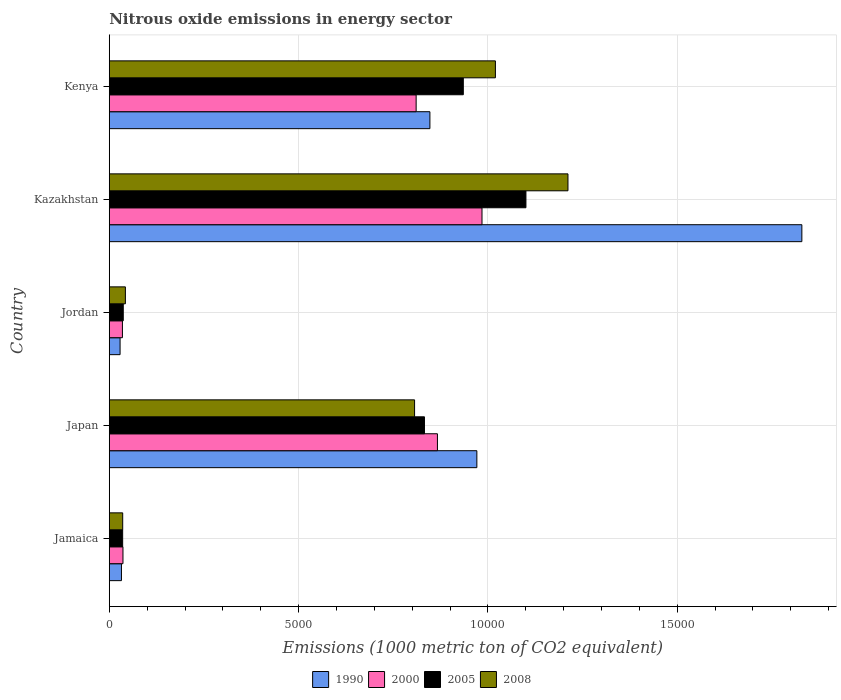How many groups of bars are there?
Offer a very short reply. 5. Are the number of bars on each tick of the Y-axis equal?
Your answer should be compact. Yes. How many bars are there on the 2nd tick from the top?
Ensure brevity in your answer.  4. How many bars are there on the 2nd tick from the bottom?
Your answer should be compact. 4. What is the label of the 4th group of bars from the top?
Provide a succinct answer. Japan. In how many cases, is the number of bars for a given country not equal to the number of legend labels?
Provide a succinct answer. 0. What is the amount of nitrous oxide emitted in 1990 in Jamaica?
Your answer should be very brief. 321.7. Across all countries, what is the maximum amount of nitrous oxide emitted in 2005?
Your answer should be very brief. 1.10e+04. Across all countries, what is the minimum amount of nitrous oxide emitted in 2005?
Your answer should be very brief. 353.5. In which country was the amount of nitrous oxide emitted in 2008 maximum?
Ensure brevity in your answer.  Kazakhstan. In which country was the amount of nitrous oxide emitted in 1990 minimum?
Ensure brevity in your answer.  Jordan. What is the total amount of nitrous oxide emitted in 2008 in the graph?
Provide a short and direct response. 3.12e+04. What is the difference between the amount of nitrous oxide emitted in 2008 in Japan and that in Kazakhstan?
Ensure brevity in your answer.  -4051.4. What is the difference between the amount of nitrous oxide emitted in 2008 in Kazakhstan and the amount of nitrous oxide emitted in 1990 in Kenya?
Provide a succinct answer. 3646.6. What is the average amount of nitrous oxide emitted in 1990 per country?
Your answer should be very brief. 7415.42. What is the difference between the amount of nitrous oxide emitted in 1990 and amount of nitrous oxide emitted in 2005 in Jordan?
Provide a succinct answer. -83.9. What is the ratio of the amount of nitrous oxide emitted in 2008 in Jamaica to that in Kenya?
Your answer should be compact. 0.03. Is the amount of nitrous oxide emitted in 2000 in Jamaica less than that in Kazakhstan?
Offer a terse response. Yes. What is the difference between the highest and the second highest amount of nitrous oxide emitted in 2005?
Your response must be concise. 1654. What is the difference between the highest and the lowest amount of nitrous oxide emitted in 2000?
Provide a succinct answer. 9497.1. Is the sum of the amount of nitrous oxide emitted in 2008 in Jamaica and Kazakhstan greater than the maximum amount of nitrous oxide emitted in 2005 across all countries?
Ensure brevity in your answer.  Yes. Is it the case that in every country, the sum of the amount of nitrous oxide emitted in 2005 and amount of nitrous oxide emitted in 1990 is greater than the sum of amount of nitrous oxide emitted in 2000 and amount of nitrous oxide emitted in 2008?
Your answer should be very brief. No. What does the 2nd bar from the bottom in Kenya represents?
Ensure brevity in your answer.  2000. How many bars are there?
Give a very brief answer. 20. Are all the bars in the graph horizontal?
Provide a succinct answer. Yes. How many countries are there in the graph?
Offer a very short reply. 5. Does the graph contain grids?
Provide a succinct answer. Yes. Where does the legend appear in the graph?
Make the answer very short. Bottom center. How many legend labels are there?
Provide a succinct answer. 4. How are the legend labels stacked?
Your answer should be compact. Horizontal. What is the title of the graph?
Offer a very short reply. Nitrous oxide emissions in energy sector. What is the label or title of the X-axis?
Offer a terse response. Emissions (1000 metric ton of CO2 equivalent). What is the label or title of the Y-axis?
Make the answer very short. Country. What is the Emissions (1000 metric ton of CO2 equivalent) in 1990 in Jamaica?
Provide a short and direct response. 321.7. What is the Emissions (1000 metric ton of CO2 equivalent) in 2000 in Jamaica?
Provide a succinct answer. 361.6. What is the Emissions (1000 metric ton of CO2 equivalent) in 2005 in Jamaica?
Keep it short and to the point. 353.5. What is the Emissions (1000 metric ton of CO2 equivalent) in 2008 in Jamaica?
Ensure brevity in your answer.  354.8. What is the Emissions (1000 metric ton of CO2 equivalent) of 1990 in Japan?
Your answer should be very brief. 9708.8. What is the Emissions (1000 metric ton of CO2 equivalent) of 2000 in Japan?
Your response must be concise. 8667.2. What is the Emissions (1000 metric ton of CO2 equivalent) in 2005 in Japan?
Your response must be concise. 8324.7. What is the Emissions (1000 metric ton of CO2 equivalent) of 2008 in Japan?
Provide a succinct answer. 8063.7. What is the Emissions (1000 metric ton of CO2 equivalent) in 1990 in Jordan?
Give a very brief answer. 285.6. What is the Emissions (1000 metric ton of CO2 equivalent) of 2000 in Jordan?
Keep it short and to the point. 347.2. What is the Emissions (1000 metric ton of CO2 equivalent) in 2005 in Jordan?
Ensure brevity in your answer.  369.5. What is the Emissions (1000 metric ton of CO2 equivalent) in 2008 in Jordan?
Ensure brevity in your answer.  425.7. What is the Emissions (1000 metric ton of CO2 equivalent) in 1990 in Kazakhstan?
Your answer should be compact. 1.83e+04. What is the Emissions (1000 metric ton of CO2 equivalent) in 2000 in Kazakhstan?
Your response must be concise. 9844.3. What is the Emissions (1000 metric ton of CO2 equivalent) in 2005 in Kazakhstan?
Make the answer very short. 1.10e+04. What is the Emissions (1000 metric ton of CO2 equivalent) of 2008 in Kazakhstan?
Offer a terse response. 1.21e+04. What is the Emissions (1000 metric ton of CO2 equivalent) in 1990 in Kenya?
Ensure brevity in your answer.  8468.5. What is the Emissions (1000 metric ton of CO2 equivalent) of 2000 in Kenya?
Provide a succinct answer. 8105.1. What is the Emissions (1000 metric ton of CO2 equivalent) of 2005 in Kenya?
Ensure brevity in your answer.  9351. What is the Emissions (1000 metric ton of CO2 equivalent) of 2008 in Kenya?
Offer a very short reply. 1.02e+04. Across all countries, what is the maximum Emissions (1000 metric ton of CO2 equivalent) of 1990?
Your response must be concise. 1.83e+04. Across all countries, what is the maximum Emissions (1000 metric ton of CO2 equivalent) in 2000?
Make the answer very short. 9844.3. Across all countries, what is the maximum Emissions (1000 metric ton of CO2 equivalent) in 2005?
Keep it short and to the point. 1.10e+04. Across all countries, what is the maximum Emissions (1000 metric ton of CO2 equivalent) of 2008?
Make the answer very short. 1.21e+04. Across all countries, what is the minimum Emissions (1000 metric ton of CO2 equivalent) of 1990?
Give a very brief answer. 285.6. Across all countries, what is the minimum Emissions (1000 metric ton of CO2 equivalent) of 2000?
Provide a short and direct response. 347.2. Across all countries, what is the minimum Emissions (1000 metric ton of CO2 equivalent) of 2005?
Your answer should be very brief. 353.5. Across all countries, what is the minimum Emissions (1000 metric ton of CO2 equivalent) in 2008?
Ensure brevity in your answer.  354.8. What is the total Emissions (1000 metric ton of CO2 equivalent) in 1990 in the graph?
Your answer should be very brief. 3.71e+04. What is the total Emissions (1000 metric ton of CO2 equivalent) of 2000 in the graph?
Provide a short and direct response. 2.73e+04. What is the total Emissions (1000 metric ton of CO2 equivalent) in 2005 in the graph?
Give a very brief answer. 2.94e+04. What is the total Emissions (1000 metric ton of CO2 equivalent) of 2008 in the graph?
Keep it short and to the point. 3.12e+04. What is the difference between the Emissions (1000 metric ton of CO2 equivalent) of 1990 in Jamaica and that in Japan?
Give a very brief answer. -9387.1. What is the difference between the Emissions (1000 metric ton of CO2 equivalent) of 2000 in Jamaica and that in Japan?
Make the answer very short. -8305.6. What is the difference between the Emissions (1000 metric ton of CO2 equivalent) in 2005 in Jamaica and that in Japan?
Keep it short and to the point. -7971.2. What is the difference between the Emissions (1000 metric ton of CO2 equivalent) of 2008 in Jamaica and that in Japan?
Offer a very short reply. -7708.9. What is the difference between the Emissions (1000 metric ton of CO2 equivalent) in 1990 in Jamaica and that in Jordan?
Offer a terse response. 36.1. What is the difference between the Emissions (1000 metric ton of CO2 equivalent) of 2000 in Jamaica and that in Jordan?
Ensure brevity in your answer.  14.4. What is the difference between the Emissions (1000 metric ton of CO2 equivalent) in 2008 in Jamaica and that in Jordan?
Give a very brief answer. -70.9. What is the difference between the Emissions (1000 metric ton of CO2 equivalent) of 1990 in Jamaica and that in Kazakhstan?
Offer a very short reply. -1.80e+04. What is the difference between the Emissions (1000 metric ton of CO2 equivalent) in 2000 in Jamaica and that in Kazakhstan?
Provide a succinct answer. -9482.7. What is the difference between the Emissions (1000 metric ton of CO2 equivalent) in 2005 in Jamaica and that in Kazakhstan?
Your response must be concise. -1.07e+04. What is the difference between the Emissions (1000 metric ton of CO2 equivalent) in 2008 in Jamaica and that in Kazakhstan?
Offer a terse response. -1.18e+04. What is the difference between the Emissions (1000 metric ton of CO2 equivalent) in 1990 in Jamaica and that in Kenya?
Your answer should be compact. -8146.8. What is the difference between the Emissions (1000 metric ton of CO2 equivalent) of 2000 in Jamaica and that in Kenya?
Give a very brief answer. -7743.5. What is the difference between the Emissions (1000 metric ton of CO2 equivalent) in 2005 in Jamaica and that in Kenya?
Your response must be concise. -8997.5. What is the difference between the Emissions (1000 metric ton of CO2 equivalent) of 2008 in Jamaica and that in Kenya?
Offer a terse response. -9843.7. What is the difference between the Emissions (1000 metric ton of CO2 equivalent) in 1990 in Japan and that in Jordan?
Keep it short and to the point. 9423.2. What is the difference between the Emissions (1000 metric ton of CO2 equivalent) of 2000 in Japan and that in Jordan?
Make the answer very short. 8320. What is the difference between the Emissions (1000 metric ton of CO2 equivalent) in 2005 in Japan and that in Jordan?
Your answer should be compact. 7955.2. What is the difference between the Emissions (1000 metric ton of CO2 equivalent) of 2008 in Japan and that in Jordan?
Make the answer very short. 7638. What is the difference between the Emissions (1000 metric ton of CO2 equivalent) of 1990 in Japan and that in Kazakhstan?
Provide a short and direct response. -8583.7. What is the difference between the Emissions (1000 metric ton of CO2 equivalent) of 2000 in Japan and that in Kazakhstan?
Ensure brevity in your answer.  -1177.1. What is the difference between the Emissions (1000 metric ton of CO2 equivalent) of 2005 in Japan and that in Kazakhstan?
Offer a very short reply. -2680.3. What is the difference between the Emissions (1000 metric ton of CO2 equivalent) in 2008 in Japan and that in Kazakhstan?
Keep it short and to the point. -4051.4. What is the difference between the Emissions (1000 metric ton of CO2 equivalent) of 1990 in Japan and that in Kenya?
Provide a succinct answer. 1240.3. What is the difference between the Emissions (1000 metric ton of CO2 equivalent) in 2000 in Japan and that in Kenya?
Offer a very short reply. 562.1. What is the difference between the Emissions (1000 metric ton of CO2 equivalent) in 2005 in Japan and that in Kenya?
Your response must be concise. -1026.3. What is the difference between the Emissions (1000 metric ton of CO2 equivalent) of 2008 in Japan and that in Kenya?
Offer a terse response. -2134.8. What is the difference between the Emissions (1000 metric ton of CO2 equivalent) of 1990 in Jordan and that in Kazakhstan?
Offer a very short reply. -1.80e+04. What is the difference between the Emissions (1000 metric ton of CO2 equivalent) in 2000 in Jordan and that in Kazakhstan?
Your response must be concise. -9497.1. What is the difference between the Emissions (1000 metric ton of CO2 equivalent) in 2005 in Jordan and that in Kazakhstan?
Your answer should be very brief. -1.06e+04. What is the difference between the Emissions (1000 metric ton of CO2 equivalent) of 2008 in Jordan and that in Kazakhstan?
Provide a succinct answer. -1.17e+04. What is the difference between the Emissions (1000 metric ton of CO2 equivalent) of 1990 in Jordan and that in Kenya?
Your response must be concise. -8182.9. What is the difference between the Emissions (1000 metric ton of CO2 equivalent) of 2000 in Jordan and that in Kenya?
Provide a short and direct response. -7757.9. What is the difference between the Emissions (1000 metric ton of CO2 equivalent) of 2005 in Jordan and that in Kenya?
Make the answer very short. -8981.5. What is the difference between the Emissions (1000 metric ton of CO2 equivalent) of 2008 in Jordan and that in Kenya?
Offer a terse response. -9772.8. What is the difference between the Emissions (1000 metric ton of CO2 equivalent) in 1990 in Kazakhstan and that in Kenya?
Ensure brevity in your answer.  9824. What is the difference between the Emissions (1000 metric ton of CO2 equivalent) in 2000 in Kazakhstan and that in Kenya?
Your response must be concise. 1739.2. What is the difference between the Emissions (1000 metric ton of CO2 equivalent) of 2005 in Kazakhstan and that in Kenya?
Make the answer very short. 1654. What is the difference between the Emissions (1000 metric ton of CO2 equivalent) in 2008 in Kazakhstan and that in Kenya?
Your answer should be compact. 1916.6. What is the difference between the Emissions (1000 metric ton of CO2 equivalent) in 1990 in Jamaica and the Emissions (1000 metric ton of CO2 equivalent) in 2000 in Japan?
Offer a very short reply. -8345.5. What is the difference between the Emissions (1000 metric ton of CO2 equivalent) in 1990 in Jamaica and the Emissions (1000 metric ton of CO2 equivalent) in 2005 in Japan?
Make the answer very short. -8003. What is the difference between the Emissions (1000 metric ton of CO2 equivalent) of 1990 in Jamaica and the Emissions (1000 metric ton of CO2 equivalent) of 2008 in Japan?
Provide a succinct answer. -7742. What is the difference between the Emissions (1000 metric ton of CO2 equivalent) in 2000 in Jamaica and the Emissions (1000 metric ton of CO2 equivalent) in 2005 in Japan?
Offer a very short reply. -7963.1. What is the difference between the Emissions (1000 metric ton of CO2 equivalent) in 2000 in Jamaica and the Emissions (1000 metric ton of CO2 equivalent) in 2008 in Japan?
Your answer should be compact. -7702.1. What is the difference between the Emissions (1000 metric ton of CO2 equivalent) of 2005 in Jamaica and the Emissions (1000 metric ton of CO2 equivalent) of 2008 in Japan?
Ensure brevity in your answer.  -7710.2. What is the difference between the Emissions (1000 metric ton of CO2 equivalent) of 1990 in Jamaica and the Emissions (1000 metric ton of CO2 equivalent) of 2000 in Jordan?
Make the answer very short. -25.5. What is the difference between the Emissions (1000 metric ton of CO2 equivalent) in 1990 in Jamaica and the Emissions (1000 metric ton of CO2 equivalent) in 2005 in Jordan?
Provide a succinct answer. -47.8. What is the difference between the Emissions (1000 metric ton of CO2 equivalent) of 1990 in Jamaica and the Emissions (1000 metric ton of CO2 equivalent) of 2008 in Jordan?
Offer a very short reply. -104. What is the difference between the Emissions (1000 metric ton of CO2 equivalent) in 2000 in Jamaica and the Emissions (1000 metric ton of CO2 equivalent) in 2005 in Jordan?
Offer a terse response. -7.9. What is the difference between the Emissions (1000 metric ton of CO2 equivalent) of 2000 in Jamaica and the Emissions (1000 metric ton of CO2 equivalent) of 2008 in Jordan?
Ensure brevity in your answer.  -64.1. What is the difference between the Emissions (1000 metric ton of CO2 equivalent) of 2005 in Jamaica and the Emissions (1000 metric ton of CO2 equivalent) of 2008 in Jordan?
Your answer should be very brief. -72.2. What is the difference between the Emissions (1000 metric ton of CO2 equivalent) of 1990 in Jamaica and the Emissions (1000 metric ton of CO2 equivalent) of 2000 in Kazakhstan?
Ensure brevity in your answer.  -9522.6. What is the difference between the Emissions (1000 metric ton of CO2 equivalent) in 1990 in Jamaica and the Emissions (1000 metric ton of CO2 equivalent) in 2005 in Kazakhstan?
Offer a terse response. -1.07e+04. What is the difference between the Emissions (1000 metric ton of CO2 equivalent) of 1990 in Jamaica and the Emissions (1000 metric ton of CO2 equivalent) of 2008 in Kazakhstan?
Provide a succinct answer. -1.18e+04. What is the difference between the Emissions (1000 metric ton of CO2 equivalent) in 2000 in Jamaica and the Emissions (1000 metric ton of CO2 equivalent) in 2005 in Kazakhstan?
Your answer should be compact. -1.06e+04. What is the difference between the Emissions (1000 metric ton of CO2 equivalent) of 2000 in Jamaica and the Emissions (1000 metric ton of CO2 equivalent) of 2008 in Kazakhstan?
Offer a very short reply. -1.18e+04. What is the difference between the Emissions (1000 metric ton of CO2 equivalent) in 2005 in Jamaica and the Emissions (1000 metric ton of CO2 equivalent) in 2008 in Kazakhstan?
Provide a short and direct response. -1.18e+04. What is the difference between the Emissions (1000 metric ton of CO2 equivalent) of 1990 in Jamaica and the Emissions (1000 metric ton of CO2 equivalent) of 2000 in Kenya?
Your answer should be compact. -7783.4. What is the difference between the Emissions (1000 metric ton of CO2 equivalent) in 1990 in Jamaica and the Emissions (1000 metric ton of CO2 equivalent) in 2005 in Kenya?
Provide a succinct answer. -9029.3. What is the difference between the Emissions (1000 metric ton of CO2 equivalent) of 1990 in Jamaica and the Emissions (1000 metric ton of CO2 equivalent) of 2008 in Kenya?
Make the answer very short. -9876.8. What is the difference between the Emissions (1000 metric ton of CO2 equivalent) of 2000 in Jamaica and the Emissions (1000 metric ton of CO2 equivalent) of 2005 in Kenya?
Ensure brevity in your answer.  -8989.4. What is the difference between the Emissions (1000 metric ton of CO2 equivalent) in 2000 in Jamaica and the Emissions (1000 metric ton of CO2 equivalent) in 2008 in Kenya?
Provide a short and direct response. -9836.9. What is the difference between the Emissions (1000 metric ton of CO2 equivalent) in 2005 in Jamaica and the Emissions (1000 metric ton of CO2 equivalent) in 2008 in Kenya?
Give a very brief answer. -9845. What is the difference between the Emissions (1000 metric ton of CO2 equivalent) in 1990 in Japan and the Emissions (1000 metric ton of CO2 equivalent) in 2000 in Jordan?
Provide a succinct answer. 9361.6. What is the difference between the Emissions (1000 metric ton of CO2 equivalent) of 1990 in Japan and the Emissions (1000 metric ton of CO2 equivalent) of 2005 in Jordan?
Offer a terse response. 9339.3. What is the difference between the Emissions (1000 metric ton of CO2 equivalent) of 1990 in Japan and the Emissions (1000 metric ton of CO2 equivalent) of 2008 in Jordan?
Keep it short and to the point. 9283.1. What is the difference between the Emissions (1000 metric ton of CO2 equivalent) in 2000 in Japan and the Emissions (1000 metric ton of CO2 equivalent) in 2005 in Jordan?
Provide a succinct answer. 8297.7. What is the difference between the Emissions (1000 metric ton of CO2 equivalent) of 2000 in Japan and the Emissions (1000 metric ton of CO2 equivalent) of 2008 in Jordan?
Offer a very short reply. 8241.5. What is the difference between the Emissions (1000 metric ton of CO2 equivalent) in 2005 in Japan and the Emissions (1000 metric ton of CO2 equivalent) in 2008 in Jordan?
Offer a very short reply. 7899. What is the difference between the Emissions (1000 metric ton of CO2 equivalent) of 1990 in Japan and the Emissions (1000 metric ton of CO2 equivalent) of 2000 in Kazakhstan?
Your answer should be compact. -135.5. What is the difference between the Emissions (1000 metric ton of CO2 equivalent) of 1990 in Japan and the Emissions (1000 metric ton of CO2 equivalent) of 2005 in Kazakhstan?
Provide a succinct answer. -1296.2. What is the difference between the Emissions (1000 metric ton of CO2 equivalent) of 1990 in Japan and the Emissions (1000 metric ton of CO2 equivalent) of 2008 in Kazakhstan?
Provide a short and direct response. -2406.3. What is the difference between the Emissions (1000 metric ton of CO2 equivalent) of 2000 in Japan and the Emissions (1000 metric ton of CO2 equivalent) of 2005 in Kazakhstan?
Make the answer very short. -2337.8. What is the difference between the Emissions (1000 metric ton of CO2 equivalent) of 2000 in Japan and the Emissions (1000 metric ton of CO2 equivalent) of 2008 in Kazakhstan?
Offer a terse response. -3447.9. What is the difference between the Emissions (1000 metric ton of CO2 equivalent) of 2005 in Japan and the Emissions (1000 metric ton of CO2 equivalent) of 2008 in Kazakhstan?
Your answer should be compact. -3790.4. What is the difference between the Emissions (1000 metric ton of CO2 equivalent) in 1990 in Japan and the Emissions (1000 metric ton of CO2 equivalent) in 2000 in Kenya?
Make the answer very short. 1603.7. What is the difference between the Emissions (1000 metric ton of CO2 equivalent) of 1990 in Japan and the Emissions (1000 metric ton of CO2 equivalent) of 2005 in Kenya?
Offer a very short reply. 357.8. What is the difference between the Emissions (1000 metric ton of CO2 equivalent) in 1990 in Japan and the Emissions (1000 metric ton of CO2 equivalent) in 2008 in Kenya?
Ensure brevity in your answer.  -489.7. What is the difference between the Emissions (1000 metric ton of CO2 equivalent) of 2000 in Japan and the Emissions (1000 metric ton of CO2 equivalent) of 2005 in Kenya?
Offer a very short reply. -683.8. What is the difference between the Emissions (1000 metric ton of CO2 equivalent) in 2000 in Japan and the Emissions (1000 metric ton of CO2 equivalent) in 2008 in Kenya?
Offer a very short reply. -1531.3. What is the difference between the Emissions (1000 metric ton of CO2 equivalent) of 2005 in Japan and the Emissions (1000 metric ton of CO2 equivalent) of 2008 in Kenya?
Keep it short and to the point. -1873.8. What is the difference between the Emissions (1000 metric ton of CO2 equivalent) of 1990 in Jordan and the Emissions (1000 metric ton of CO2 equivalent) of 2000 in Kazakhstan?
Your response must be concise. -9558.7. What is the difference between the Emissions (1000 metric ton of CO2 equivalent) of 1990 in Jordan and the Emissions (1000 metric ton of CO2 equivalent) of 2005 in Kazakhstan?
Your answer should be very brief. -1.07e+04. What is the difference between the Emissions (1000 metric ton of CO2 equivalent) in 1990 in Jordan and the Emissions (1000 metric ton of CO2 equivalent) in 2008 in Kazakhstan?
Your answer should be very brief. -1.18e+04. What is the difference between the Emissions (1000 metric ton of CO2 equivalent) of 2000 in Jordan and the Emissions (1000 metric ton of CO2 equivalent) of 2005 in Kazakhstan?
Keep it short and to the point. -1.07e+04. What is the difference between the Emissions (1000 metric ton of CO2 equivalent) in 2000 in Jordan and the Emissions (1000 metric ton of CO2 equivalent) in 2008 in Kazakhstan?
Offer a very short reply. -1.18e+04. What is the difference between the Emissions (1000 metric ton of CO2 equivalent) in 2005 in Jordan and the Emissions (1000 metric ton of CO2 equivalent) in 2008 in Kazakhstan?
Provide a short and direct response. -1.17e+04. What is the difference between the Emissions (1000 metric ton of CO2 equivalent) of 1990 in Jordan and the Emissions (1000 metric ton of CO2 equivalent) of 2000 in Kenya?
Ensure brevity in your answer.  -7819.5. What is the difference between the Emissions (1000 metric ton of CO2 equivalent) of 1990 in Jordan and the Emissions (1000 metric ton of CO2 equivalent) of 2005 in Kenya?
Your response must be concise. -9065.4. What is the difference between the Emissions (1000 metric ton of CO2 equivalent) in 1990 in Jordan and the Emissions (1000 metric ton of CO2 equivalent) in 2008 in Kenya?
Give a very brief answer. -9912.9. What is the difference between the Emissions (1000 metric ton of CO2 equivalent) in 2000 in Jordan and the Emissions (1000 metric ton of CO2 equivalent) in 2005 in Kenya?
Your response must be concise. -9003.8. What is the difference between the Emissions (1000 metric ton of CO2 equivalent) of 2000 in Jordan and the Emissions (1000 metric ton of CO2 equivalent) of 2008 in Kenya?
Make the answer very short. -9851.3. What is the difference between the Emissions (1000 metric ton of CO2 equivalent) of 2005 in Jordan and the Emissions (1000 metric ton of CO2 equivalent) of 2008 in Kenya?
Give a very brief answer. -9829. What is the difference between the Emissions (1000 metric ton of CO2 equivalent) in 1990 in Kazakhstan and the Emissions (1000 metric ton of CO2 equivalent) in 2000 in Kenya?
Make the answer very short. 1.02e+04. What is the difference between the Emissions (1000 metric ton of CO2 equivalent) of 1990 in Kazakhstan and the Emissions (1000 metric ton of CO2 equivalent) of 2005 in Kenya?
Your response must be concise. 8941.5. What is the difference between the Emissions (1000 metric ton of CO2 equivalent) in 1990 in Kazakhstan and the Emissions (1000 metric ton of CO2 equivalent) in 2008 in Kenya?
Your answer should be very brief. 8094. What is the difference between the Emissions (1000 metric ton of CO2 equivalent) of 2000 in Kazakhstan and the Emissions (1000 metric ton of CO2 equivalent) of 2005 in Kenya?
Your answer should be very brief. 493.3. What is the difference between the Emissions (1000 metric ton of CO2 equivalent) in 2000 in Kazakhstan and the Emissions (1000 metric ton of CO2 equivalent) in 2008 in Kenya?
Your answer should be compact. -354.2. What is the difference between the Emissions (1000 metric ton of CO2 equivalent) of 2005 in Kazakhstan and the Emissions (1000 metric ton of CO2 equivalent) of 2008 in Kenya?
Your response must be concise. 806.5. What is the average Emissions (1000 metric ton of CO2 equivalent) in 1990 per country?
Offer a terse response. 7415.42. What is the average Emissions (1000 metric ton of CO2 equivalent) in 2000 per country?
Keep it short and to the point. 5465.08. What is the average Emissions (1000 metric ton of CO2 equivalent) of 2005 per country?
Offer a terse response. 5880.74. What is the average Emissions (1000 metric ton of CO2 equivalent) of 2008 per country?
Ensure brevity in your answer.  6231.56. What is the difference between the Emissions (1000 metric ton of CO2 equivalent) of 1990 and Emissions (1000 metric ton of CO2 equivalent) of 2000 in Jamaica?
Offer a terse response. -39.9. What is the difference between the Emissions (1000 metric ton of CO2 equivalent) in 1990 and Emissions (1000 metric ton of CO2 equivalent) in 2005 in Jamaica?
Provide a succinct answer. -31.8. What is the difference between the Emissions (1000 metric ton of CO2 equivalent) of 1990 and Emissions (1000 metric ton of CO2 equivalent) of 2008 in Jamaica?
Offer a terse response. -33.1. What is the difference between the Emissions (1000 metric ton of CO2 equivalent) of 2005 and Emissions (1000 metric ton of CO2 equivalent) of 2008 in Jamaica?
Keep it short and to the point. -1.3. What is the difference between the Emissions (1000 metric ton of CO2 equivalent) of 1990 and Emissions (1000 metric ton of CO2 equivalent) of 2000 in Japan?
Your response must be concise. 1041.6. What is the difference between the Emissions (1000 metric ton of CO2 equivalent) of 1990 and Emissions (1000 metric ton of CO2 equivalent) of 2005 in Japan?
Your response must be concise. 1384.1. What is the difference between the Emissions (1000 metric ton of CO2 equivalent) in 1990 and Emissions (1000 metric ton of CO2 equivalent) in 2008 in Japan?
Provide a succinct answer. 1645.1. What is the difference between the Emissions (1000 metric ton of CO2 equivalent) of 2000 and Emissions (1000 metric ton of CO2 equivalent) of 2005 in Japan?
Ensure brevity in your answer.  342.5. What is the difference between the Emissions (1000 metric ton of CO2 equivalent) in 2000 and Emissions (1000 metric ton of CO2 equivalent) in 2008 in Japan?
Your response must be concise. 603.5. What is the difference between the Emissions (1000 metric ton of CO2 equivalent) of 2005 and Emissions (1000 metric ton of CO2 equivalent) of 2008 in Japan?
Your answer should be very brief. 261. What is the difference between the Emissions (1000 metric ton of CO2 equivalent) of 1990 and Emissions (1000 metric ton of CO2 equivalent) of 2000 in Jordan?
Make the answer very short. -61.6. What is the difference between the Emissions (1000 metric ton of CO2 equivalent) of 1990 and Emissions (1000 metric ton of CO2 equivalent) of 2005 in Jordan?
Provide a short and direct response. -83.9. What is the difference between the Emissions (1000 metric ton of CO2 equivalent) in 1990 and Emissions (1000 metric ton of CO2 equivalent) in 2008 in Jordan?
Provide a short and direct response. -140.1. What is the difference between the Emissions (1000 metric ton of CO2 equivalent) of 2000 and Emissions (1000 metric ton of CO2 equivalent) of 2005 in Jordan?
Ensure brevity in your answer.  -22.3. What is the difference between the Emissions (1000 metric ton of CO2 equivalent) in 2000 and Emissions (1000 metric ton of CO2 equivalent) in 2008 in Jordan?
Keep it short and to the point. -78.5. What is the difference between the Emissions (1000 metric ton of CO2 equivalent) of 2005 and Emissions (1000 metric ton of CO2 equivalent) of 2008 in Jordan?
Keep it short and to the point. -56.2. What is the difference between the Emissions (1000 metric ton of CO2 equivalent) of 1990 and Emissions (1000 metric ton of CO2 equivalent) of 2000 in Kazakhstan?
Offer a terse response. 8448.2. What is the difference between the Emissions (1000 metric ton of CO2 equivalent) of 1990 and Emissions (1000 metric ton of CO2 equivalent) of 2005 in Kazakhstan?
Make the answer very short. 7287.5. What is the difference between the Emissions (1000 metric ton of CO2 equivalent) in 1990 and Emissions (1000 metric ton of CO2 equivalent) in 2008 in Kazakhstan?
Offer a terse response. 6177.4. What is the difference between the Emissions (1000 metric ton of CO2 equivalent) of 2000 and Emissions (1000 metric ton of CO2 equivalent) of 2005 in Kazakhstan?
Offer a terse response. -1160.7. What is the difference between the Emissions (1000 metric ton of CO2 equivalent) in 2000 and Emissions (1000 metric ton of CO2 equivalent) in 2008 in Kazakhstan?
Give a very brief answer. -2270.8. What is the difference between the Emissions (1000 metric ton of CO2 equivalent) in 2005 and Emissions (1000 metric ton of CO2 equivalent) in 2008 in Kazakhstan?
Ensure brevity in your answer.  -1110.1. What is the difference between the Emissions (1000 metric ton of CO2 equivalent) of 1990 and Emissions (1000 metric ton of CO2 equivalent) of 2000 in Kenya?
Give a very brief answer. 363.4. What is the difference between the Emissions (1000 metric ton of CO2 equivalent) of 1990 and Emissions (1000 metric ton of CO2 equivalent) of 2005 in Kenya?
Provide a short and direct response. -882.5. What is the difference between the Emissions (1000 metric ton of CO2 equivalent) in 1990 and Emissions (1000 metric ton of CO2 equivalent) in 2008 in Kenya?
Your response must be concise. -1730. What is the difference between the Emissions (1000 metric ton of CO2 equivalent) of 2000 and Emissions (1000 metric ton of CO2 equivalent) of 2005 in Kenya?
Ensure brevity in your answer.  -1245.9. What is the difference between the Emissions (1000 metric ton of CO2 equivalent) of 2000 and Emissions (1000 metric ton of CO2 equivalent) of 2008 in Kenya?
Provide a short and direct response. -2093.4. What is the difference between the Emissions (1000 metric ton of CO2 equivalent) of 2005 and Emissions (1000 metric ton of CO2 equivalent) of 2008 in Kenya?
Make the answer very short. -847.5. What is the ratio of the Emissions (1000 metric ton of CO2 equivalent) of 1990 in Jamaica to that in Japan?
Provide a short and direct response. 0.03. What is the ratio of the Emissions (1000 metric ton of CO2 equivalent) in 2000 in Jamaica to that in Japan?
Give a very brief answer. 0.04. What is the ratio of the Emissions (1000 metric ton of CO2 equivalent) of 2005 in Jamaica to that in Japan?
Offer a terse response. 0.04. What is the ratio of the Emissions (1000 metric ton of CO2 equivalent) in 2008 in Jamaica to that in Japan?
Ensure brevity in your answer.  0.04. What is the ratio of the Emissions (1000 metric ton of CO2 equivalent) of 1990 in Jamaica to that in Jordan?
Provide a short and direct response. 1.13. What is the ratio of the Emissions (1000 metric ton of CO2 equivalent) in 2000 in Jamaica to that in Jordan?
Offer a terse response. 1.04. What is the ratio of the Emissions (1000 metric ton of CO2 equivalent) in 2005 in Jamaica to that in Jordan?
Give a very brief answer. 0.96. What is the ratio of the Emissions (1000 metric ton of CO2 equivalent) of 2008 in Jamaica to that in Jordan?
Your answer should be very brief. 0.83. What is the ratio of the Emissions (1000 metric ton of CO2 equivalent) of 1990 in Jamaica to that in Kazakhstan?
Provide a succinct answer. 0.02. What is the ratio of the Emissions (1000 metric ton of CO2 equivalent) of 2000 in Jamaica to that in Kazakhstan?
Your answer should be compact. 0.04. What is the ratio of the Emissions (1000 metric ton of CO2 equivalent) of 2005 in Jamaica to that in Kazakhstan?
Your response must be concise. 0.03. What is the ratio of the Emissions (1000 metric ton of CO2 equivalent) in 2008 in Jamaica to that in Kazakhstan?
Your response must be concise. 0.03. What is the ratio of the Emissions (1000 metric ton of CO2 equivalent) of 1990 in Jamaica to that in Kenya?
Make the answer very short. 0.04. What is the ratio of the Emissions (1000 metric ton of CO2 equivalent) in 2000 in Jamaica to that in Kenya?
Provide a short and direct response. 0.04. What is the ratio of the Emissions (1000 metric ton of CO2 equivalent) in 2005 in Jamaica to that in Kenya?
Offer a very short reply. 0.04. What is the ratio of the Emissions (1000 metric ton of CO2 equivalent) in 2008 in Jamaica to that in Kenya?
Provide a short and direct response. 0.03. What is the ratio of the Emissions (1000 metric ton of CO2 equivalent) of 1990 in Japan to that in Jordan?
Your response must be concise. 33.99. What is the ratio of the Emissions (1000 metric ton of CO2 equivalent) of 2000 in Japan to that in Jordan?
Your answer should be compact. 24.96. What is the ratio of the Emissions (1000 metric ton of CO2 equivalent) of 2005 in Japan to that in Jordan?
Provide a succinct answer. 22.53. What is the ratio of the Emissions (1000 metric ton of CO2 equivalent) in 2008 in Japan to that in Jordan?
Offer a very short reply. 18.94. What is the ratio of the Emissions (1000 metric ton of CO2 equivalent) in 1990 in Japan to that in Kazakhstan?
Ensure brevity in your answer.  0.53. What is the ratio of the Emissions (1000 metric ton of CO2 equivalent) of 2000 in Japan to that in Kazakhstan?
Ensure brevity in your answer.  0.88. What is the ratio of the Emissions (1000 metric ton of CO2 equivalent) of 2005 in Japan to that in Kazakhstan?
Ensure brevity in your answer.  0.76. What is the ratio of the Emissions (1000 metric ton of CO2 equivalent) in 2008 in Japan to that in Kazakhstan?
Provide a short and direct response. 0.67. What is the ratio of the Emissions (1000 metric ton of CO2 equivalent) in 1990 in Japan to that in Kenya?
Make the answer very short. 1.15. What is the ratio of the Emissions (1000 metric ton of CO2 equivalent) of 2000 in Japan to that in Kenya?
Provide a succinct answer. 1.07. What is the ratio of the Emissions (1000 metric ton of CO2 equivalent) in 2005 in Japan to that in Kenya?
Your answer should be very brief. 0.89. What is the ratio of the Emissions (1000 metric ton of CO2 equivalent) in 2008 in Japan to that in Kenya?
Make the answer very short. 0.79. What is the ratio of the Emissions (1000 metric ton of CO2 equivalent) in 1990 in Jordan to that in Kazakhstan?
Your answer should be very brief. 0.02. What is the ratio of the Emissions (1000 metric ton of CO2 equivalent) in 2000 in Jordan to that in Kazakhstan?
Your answer should be compact. 0.04. What is the ratio of the Emissions (1000 metric ton of CO2 equivalent) in 2005 in Jordan to that in Kazakhstan?
Offer a very short reply. 0.03. What is the ratio of the Emissions (1000 metric ton of CO2 equivalent) in 2008 in Jordan to that in Kazakhstan?
Your answer should be compact. 0.04. What is the ratio of the Emissions (1000 metric ton of CO2 equivalent) of 1990 in Jordan to that in Kenya?
Offer a terse response. 0.03. What is the ratio of the Emissions (1000 metric ton of CO2 equivalent) of 2000 in Jordan to that in Kenya?
Make the answer very short. 0.04. What is the ratio of the Emissions (1000 metric ton of CO2 equivalent) of 2005 in Jordan to that in Kenya?
Your answer should be very brief. 0.04. What is the ratio of the Emissions (1000 metric ton of CO2 equivalent) in 2008 in Jordan to that in Kenya?
Offer a very short reply. 0.04. What is the ratio of the Emissions (1000 metric ton of CO2 equivalent) in 1990 in Kazakhstan to that in Kenya?
Your response must be concise. 2.16. What is the ratio of the Emissions (1000 metric ton of CO2 equivalent) in 2000 in Kazakhstan to that in Kenya?
Your response must be concise. 1.21. What is the ratio of the Emissions (1000 metric ton of CO2 equivalent) of 2005 in Kazakhstan to that in Kenya?
Provide a short and direct response. 1.18. What is the ratio of the Emissions (1000 metric ton of CO2 equivalent) of 2008 in Kazakhstan to that in Kenya?
Provide a short and direct response. 1.19. What is the difference between the highest and the second highest Emissions (1000 metric ton of CO2 equivalent) in 1990?
Provide a succinct answer. 8583.7. What is the difference between the highest and the second highest Emissions (1000 metric ton of CO2 equivalent) in 2000?
Offer a terse response. 1177.1. What is the difference between the highest and the second highest Emissions (1000 metric ton of CO2 equivalent) of 2005?
Make the answer very short. 1654. What is the difference between the highest and the second highest Emissions (1000 metric ton of CO2 equivalent) in 2008?
Your answer should be very brief. 1916.6. What is the difference between the highest and the lowest Emissions (1000 metric ton of CO2 equivalent) of 1990?
Your answer should be very brief. 1.80e+04. What is the difference between the highest and the lowest Emissions (1000 metric ton of CO2 equivalent) of 2000?
Your answer should be very brief. 9497.1. What is the difference between the highest and the lowest Emissions (1000 metric ton of CO2 equivalent) of 2005?
Provide a short and direct response. 1.07e+04. What is the difference between the highest and the lowest Emissions (1000 metric ton of CO2 equivalent) of 2008?
Ensure brevity in your answer.  1.18e+04. 